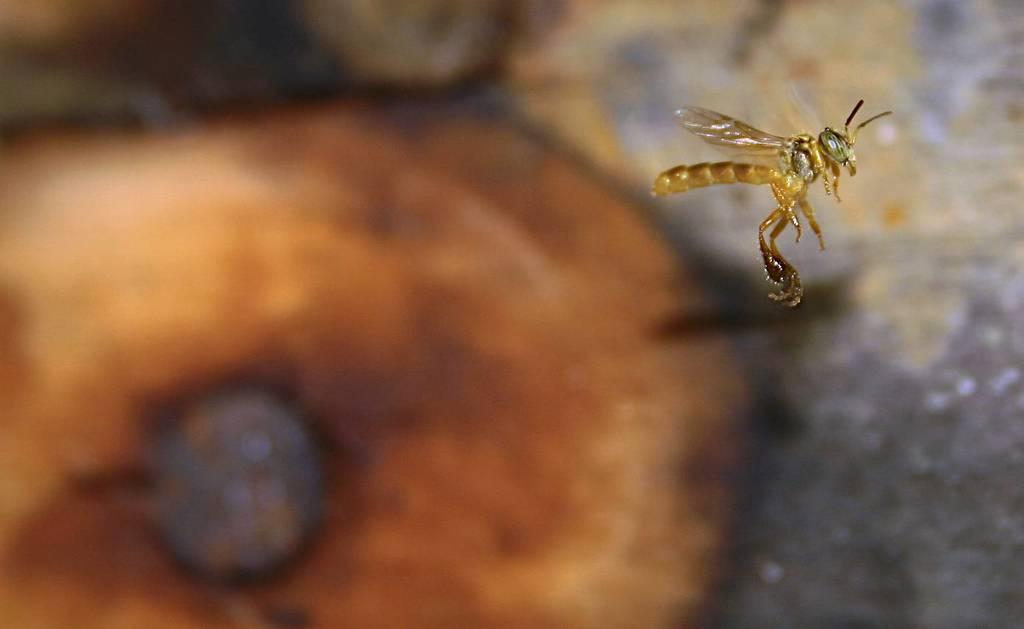Describe this image in one or two sentences. In this picture we can see an insect in the front, there is a blurry background. 